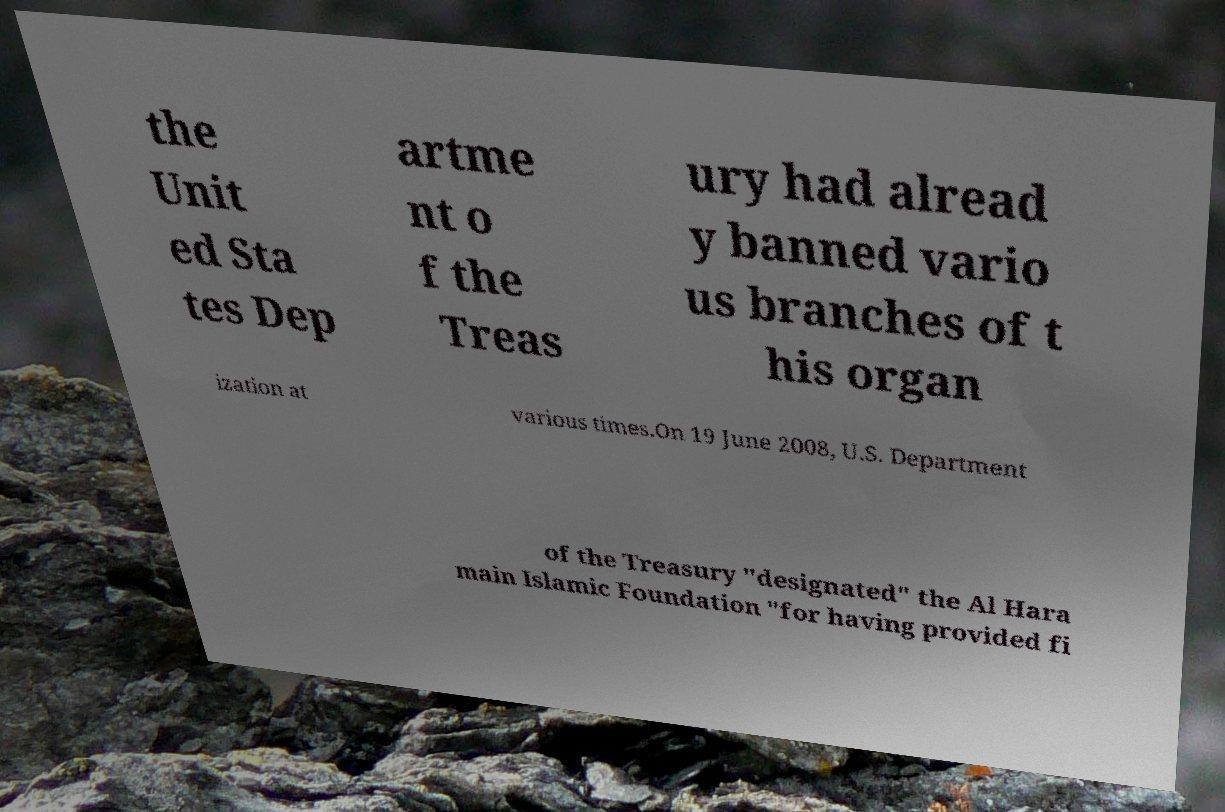What messages or text are displayed in this image? I need them in a readable, typed format. the Unit ed Sta tes Dep artme nt o f the Treas ury had alread y banned vario us branches of t his organ ization at various times.On 19 June 2008, U.S. Department of the Treasury "designated" the Al Hara main Islamic Foundation "for having provided fi 